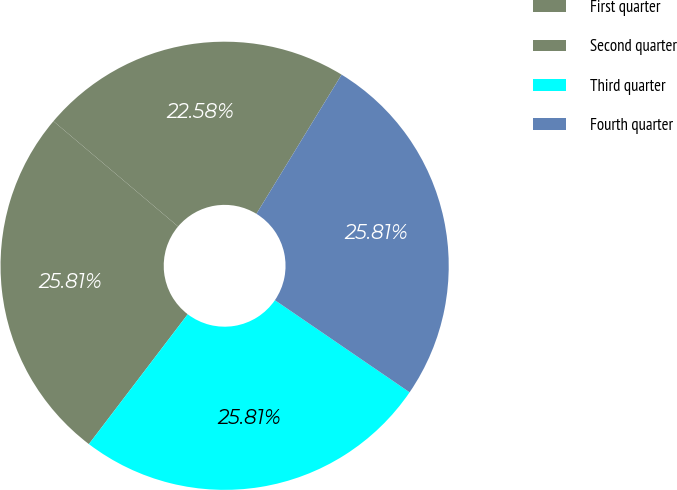Convert chart to OTSL. <chart><loc_0><loc_0><loc_500><loc_500><pie_chart><fcel>First quarter<fcel>Second quarter<fcel>Third quarter<fcel>Fourth quarter<nl><fcel>22.58%<fcel>25.81%<fcel>25.81%<fcel>25.81%<nl></chart> 